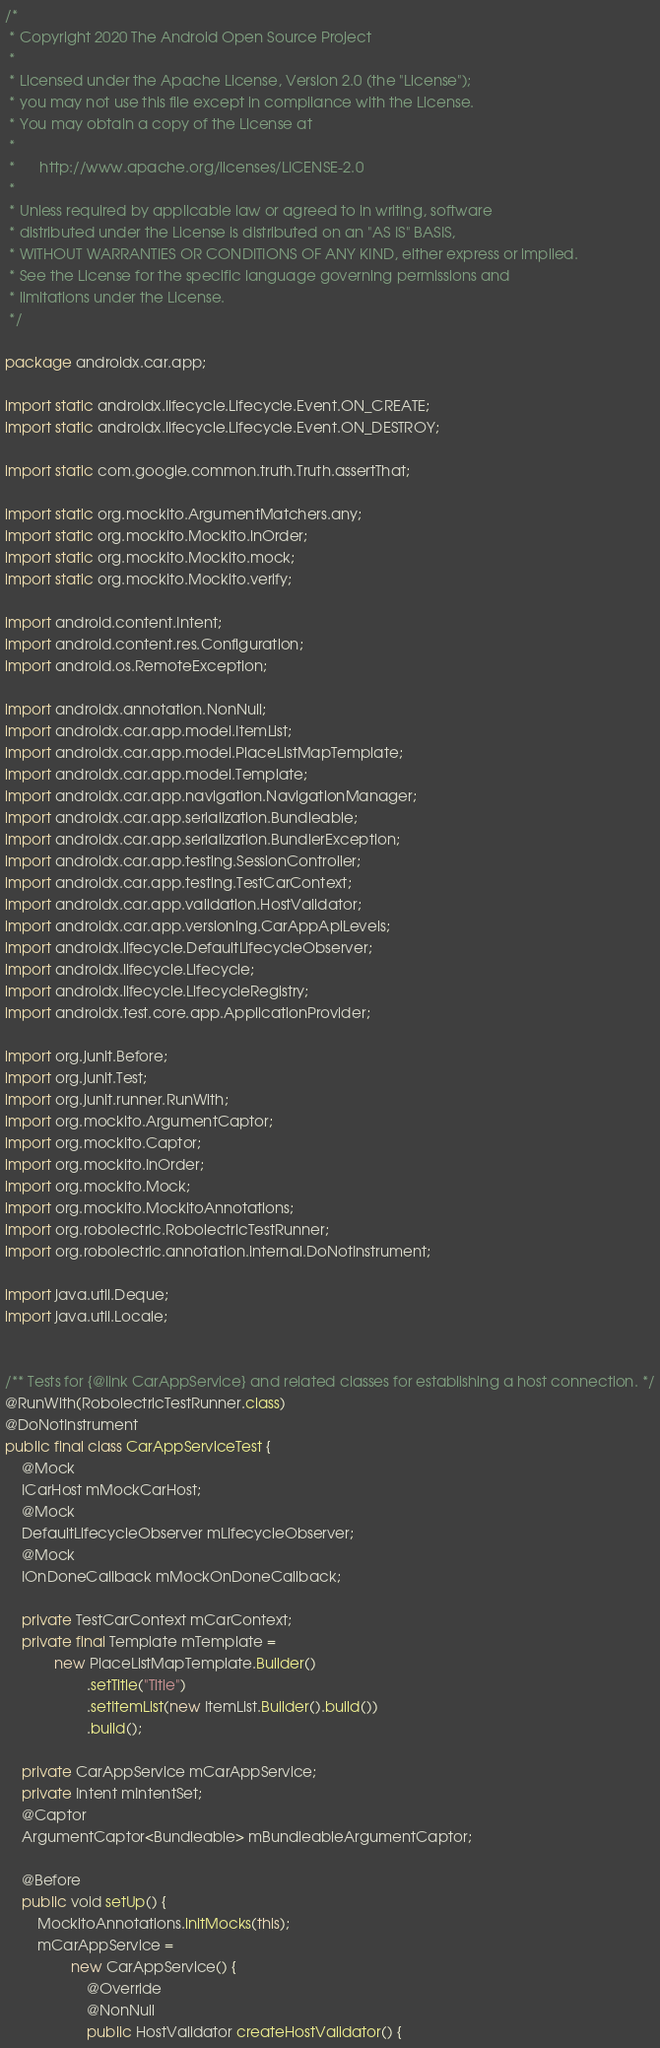Convert code to text. <code><loc_0><loc_0><loc_500><loc_500><_Java_>/*
 * Copyright 2020 The Android Open Source Project
 *
 * Licensed under the Apache License, Version 2.0 (the "License");
 * you may not use this file except in compliance with the License.
 * You may obtain a copy of the License at
 *
 *      http://www.apache.org/licenses/LICENSE-2.0
 *
 * Unless required by applicable law or agreed to in writing, software
 * distributed under the License is distributed on an "AS IS" BASIS,
 * WITHOUT WARRANTIES OR CONDITIONS OF ANY KIND, either express or implied.
 * See the License for the specific language governing permissions and
 * limitations under the License.
 */

package androidx.car.app;

import static androidx.lifecycle.Lifecycle.Event.ON_CREATE;
import static androidx.lifecycle.Lifecycle.Event.ON_DESTROY;

import static com.google.common.truth.Truth.assertThat;

import static org.mockito.ArgumentMatchers.any;
import static org.mockito.Mockito.inOrder;
import static org.mockito.Mockito.mock;
import static org.mockito.Mockito.verify;

import android.content.Intent;
import android.content.res.Configuration;
import android.os.RemoteException;

import androidx.annotation.NonNull;
import androidx.car.app.model.ItemList;
import androidx.car.app.model.PlaceListMapTemplate;
import androidx.car.app.model.Template;
import androidx.car.app.navigation.NavigationManager;
import androidx.car.app.serialization.Bundleable;
import androidx.car.app.serialization.BundlerException;
import androidx.car.app.testing.SessionController;
import androidx.car.app.testing.TestCarContext;
import androidx.car.app.validation.HostValidator;
import androidx.car.app.versioning.CarAppApiLevels;
import androidx.lifecycle.DefaultLifecycleObserver;
import androidx.lifecycle.Lifecycle;
import androidx.lifecycle.LifecycleRegistry;
import androidx.test.core.app.ApplicationProvider;

import org.junit.Before;
import org.junit.Test;
import org.junit.runner.RunWith;
import org.mockito.ArgumentCaptor;
import org.mockito.Captor;
import org.mockito.InOrder;
import org.mockito.Mock;
import org.mockito.MockitoAnnotations;
import org.robolectric.RobolectricTestRunner;
import org.robolectric.annotation.internal.DoNotInstrument;

import java.util.Deque;
import java.util.Locale;


/** Tests for {@link CarAppService} and related classes for establishing a host connection. */
@RunWith(RobolectricTestRunner.class)
@DoNotInstrument
public final class CarAppServiceTest {
    @Mock
    ICarHost mMockCarHost;
    @Mock
    DefaultLifecycleObserver mLifecycleObserver;
    @Mock
    IOnDoneCallback mMockOnDoneCallback;

    private TestCarContext mCarContext;
    private final Template mTemplate =
            new PlaceListMapTemplate.Builder()
                    .setTitle("Title")
                    .setItemList(new ItemList.Builder().build())
                    .build();

    private CarAppService mCarAppService;
    private Intent mIntentSet;
    @Captor
    ArgumentCaptor<Bundleable> mBundleableArgumentCaptor;

    @Before
    public void setUp() {
        MockitoAnnotations.initMocks(this);
        mCarAppService =
                new CarAppService() {
                    @Override
                    @NonNull
                    public HostValidator createHostValidator() {</code> 